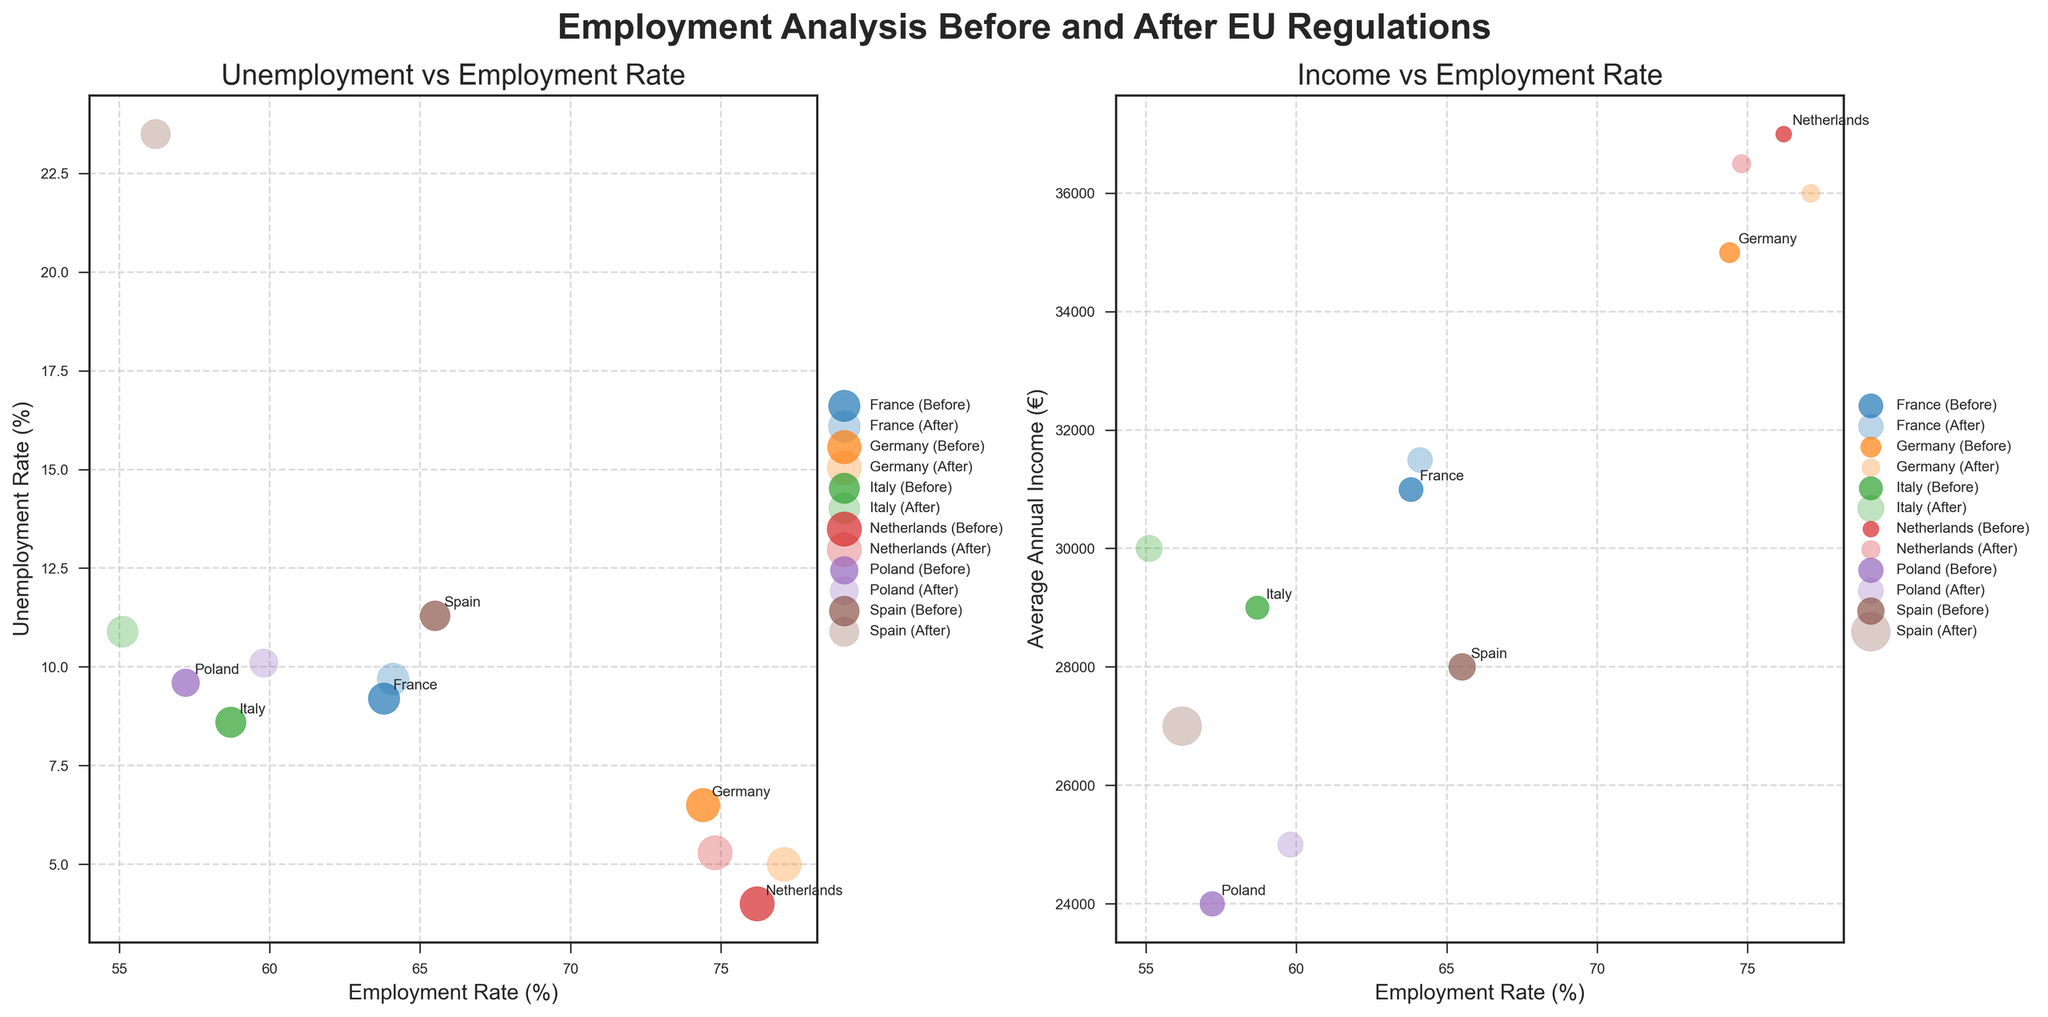What is the title of the figure? The title of the figure is located at the top center and is typically a brief summary of the plot.
Answer: Employment Analysis Before and After EU Regulations How many countries are analyzed in the figure? You can count the number of distinct groups in the legend or the number of distinct points labeled in the annotations.
Answer: 6 Which country has the largest bubble in the 'Before' scatter plot for Unemployment vs Employment Rate? Find the largest bubble in the "Before" scatter plot of 'Unemployment vs Employment Rate' subplot and identify the corresponding country from the annotations.
Answer: France What is the average annual income for Germany before the regulation? Locate Germany's 'Before' data point in either subplot, then refer to the Y-axis on the 'Income vs Employment Rate' subplot.
Answer: €35,000 Which country experienced the largest decrease in employment rate after the regulation? Compare the differences in employment rates from 'Before' to 'After' across all countries. Calculate the change for each country and identify the largest decrease.
Answer: Spain Does Poland have a higher unemployment rate before or after the regulation? Compare Poland’s data points in the 'Unemployment vs Employment Rate' subplot by looking at the respective Y-axis values for 'Before' and 'After' points.
Answer: After What is the main relationship shown in the 'Income vs Employment Rate' subplot? Describe the general trend or pattern observed between employment rate and average annual income across all data points.
Answer: Higher employment rate generally corresponds to higher average annual income Which country shows an increase in average annual income but a decrease in employment rate after the regulation? Compare the 'Before' and 'After' data points for annual income and employment rate across all countries to find any country that fits this criterion.
Answer: Italy What color is used to represent the Netherlands in the figure? Consult the datapoints labeled with Netherlands in either subplot and refer to their color, or check the legend for the corresponding color.
Answer: Purple Which country shows the highest unemployment rate after regulation? Locate the 'After' data points in the 'Unemployment vs Employment Rate' subplot and identify the country with the highest Y-axis value.
Answer: Spain 